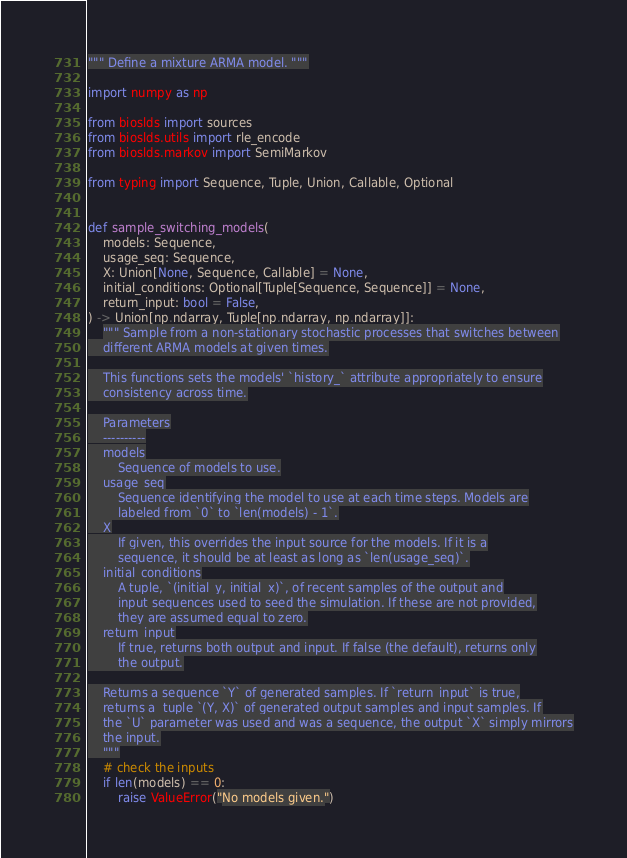Convert code to text. <code><loc_0><loc_0><loc_500><loc_500><_Python_>""" Define a mixture ARMA model. """

import numpy as np

from bioslds import sources
from bioslds.utils import rle_encode
from bioslds.markov import SemiMarkov

from typing import Sequence, Tuple, Union, Callable, Optional


def sample_switching_models(
    models: Sequence,
    usage_seq: Sequence,
    X: Union[None, Sequence, Callable] = None,
    initial_conditions: Optional[Tuple[Sequence, Sequence]] = None,
    return_input: bool = False,
) -> Union[np.ndarray, Tuple[np.ndarray, np.ndarray]]:
    """ Sample from a non-stationary stochastic processes that switches between
    different ARMA models at given times.

    This functions sets the models' `history_` attribute appropriately to ensure
    consistency across time.

    Parameters
    ----------
    models
        Sequence of models to use.
    usage_seq
        Sequence identifying the model to use at each time steps. Models are
        labeled from `0` to `len(models) - 1`.
    X
        If given, this overrides the input source for the models. If it is a
        sequence, it should be at least as long as `len(usage_seq)`.
    initial_conditions
        A tuple, `(initial_y, initial_x)`, of recent samples of the output and
        input sequences used to seed the simulation. If these are not provided,
        they are assumed equal to zero.
    return_input
        If true, returns both output and input. If false (the default), returns only
        the output.

    Returns a sequence `Y` of generated samples. If `return_input` is true,
    returns a  tuple `(Y, X)` of generated output samples and input samples. If
    the `U` parameter was used and was a sequence, the output `X` simply mirrors
    the input.
    """
    # check the inputs
    if len(models) == 0:
        raise ValueError("No models given.")
</code> 